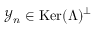<formula> <loc_0><loc_0><loc_500><loc_500>\mathcal { Y } _ { n } \in K e r ( \Lambda ) ^ { \perp }</formula> 